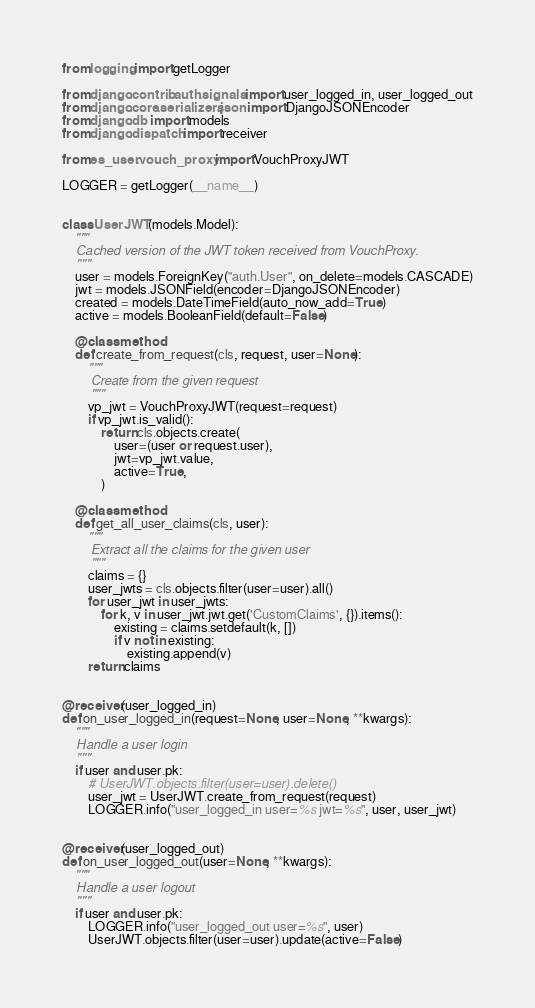<code> <loc_0><loc_0><loc_500><loc_500><_Python_>from logging import getLogger

from django.contrib.auth.signals import user_logged_in, user_logged_out
from django.core.serializers.json import DjangoJSONEncoder
from django.db import models
from django.dispatch import receiver

from es_user.vouch_proxy import VouchProxyJWT

LOGGER = getLogger(__name__)


class UserJWT(models.Model):
    """
    Cached version of the JWT token received from VouchProxy.
    """
    user = models.ForeignKey("auth.User", on_delete=models.CASCADE)
    jwt = models.JSONField(encoder=DjangoJSONEncoder)
    created = models.DateTimeField(auto_now_add=True)
    active = models.BooleanField(default=False)

    @classmethod
    def create_from_request(cls, request, user=None):
        """
        Create from the given request
        """
        vp_jwt = VouchProxyJWT(request=request)
        if vp_jwt.is_valid():
            return cls.objects.create(
                user=(user or request.user),
                jwt=vp_jwt.value,
                active=True,
            )

    @classmethod
    def get_all_user_claims(cls, user):
        """
        Extract all the claims for the given user
        """
        claims = {}
        user_jwts = cls.objects.filter(user=user).all()
        for user_jwt in user_jwts:
            for k, v in user_jwt.jwt.get('CustomClaims', {}).items():
                existing = claims.setdefault(k, [])
                if v not in existing:
                    existing.append(v)
        return claims


@receiver(user_logged_in)
def on_user_logged_in(request=None, user=None, **kwargs):
    """
    Handle a user login
    """
    if user and user.pk:
        # UserJWT.objects.filter(user=user).delete()
        user_jwt = UserJWT.create_from_request(request)
        LOGGER.info("user_logged_in user=%s jwt=%s", user, user_jwt)


@receiver(user_logged_out)
def on_user_logged_out(user=None, **kwargs):
    """
    Handle a user logout
    """
    if user and user.pk:
        LOGGER.info("user_logged_out user=%s", user)
        UserJWT.objects.filter(user=user).update(active=False)
</code> 